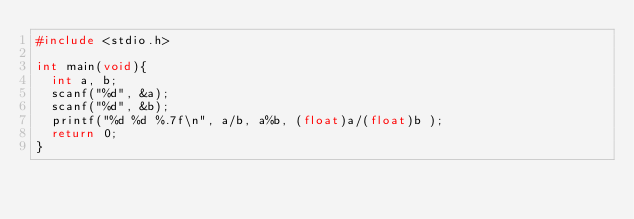Convert code to text. <code><loc_0><loc_0><loc_500><loc_500><_C_>#include <stdio.h>

int main(void){
	int a, b;
	scanf("%d", &a);
	scanf("%d", &b);
	printf("%d %d %.7f\n", a/b, a%b, (float)a/(float)b );
	return 0;
}</code> 